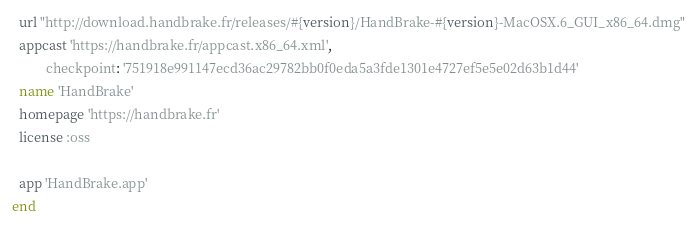<code> <loc_0><loc_0><loc_500><loc_500><_Ruby_>  url "http://download.handbrake.fr/releases/#{version}/HandBrake-#{version}-MacOSX.6_GUI_x86_64.dmg"
  appcast 'https://handbrake.fr/appcast.x86_64.xml',
          checkpoint: '751918e991147ecd36ac29782bb0f0eda5a3fde1301e4727ef5e5e02d63b1d44'
  name 'HandBrake'
  homepage 'https://handbrake.fr'
  license :oss

  app 'HandBrake.app'
end
</code> 